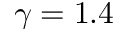<formula> <loc_0><loc_0><loc_500><loc_500>\gamma = 1 . 4</formula> 